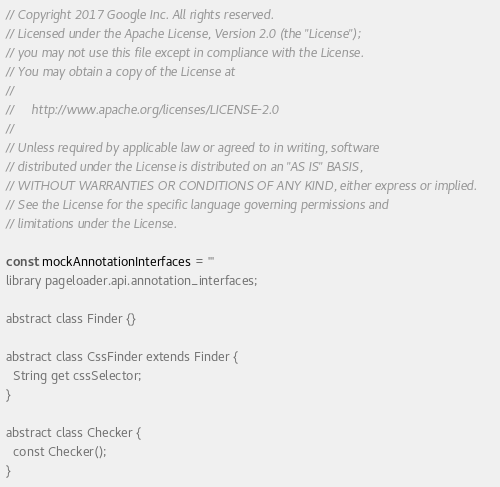Convert code to text. <code><loc_0><loc_0><loc_500><loc_500><_Dart_>// Copyright 2017 Google Inc. All rights reserved.
// Licensed under the Apache License, Version 2.0 (the "License");
// you may not use this file except in compliance with the License.
// You may obtain a copy of the License at
//
//     http://www.apache.org/licenses/LICENSE-2.0
//
// Unless required by applicable law or agreed to in writing, software
// distributed under the License is distributed on an "AS IS" BASIS,
// WITHOUT WARRANTIES OR CONDITIONS OF ANY KIND, either express or implied.
// See the License for the specific language governing permissions and
// limitations under the License.

const mockAnnotationInterfaces = '''
library pageloader.api.annotation_interfaces;

abstract class Finder {}

abstract class CssFinder extends Finder {
  String get cssSelector;
}

abstract class Checker {
  const Checker();
}
</code> 